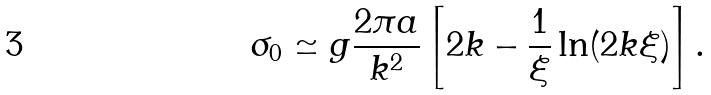Convert formula to latex. <formula><loc_0><loc_0><loc_500><loc_500>\sigma _ { 0 } \simeq g \frac { 2 \pi a } { k ^ { 2 } } \left [ 2 k - \frac { 1 } { \xi } \ln ( 2 k \xi ) \right ] .</formula> 